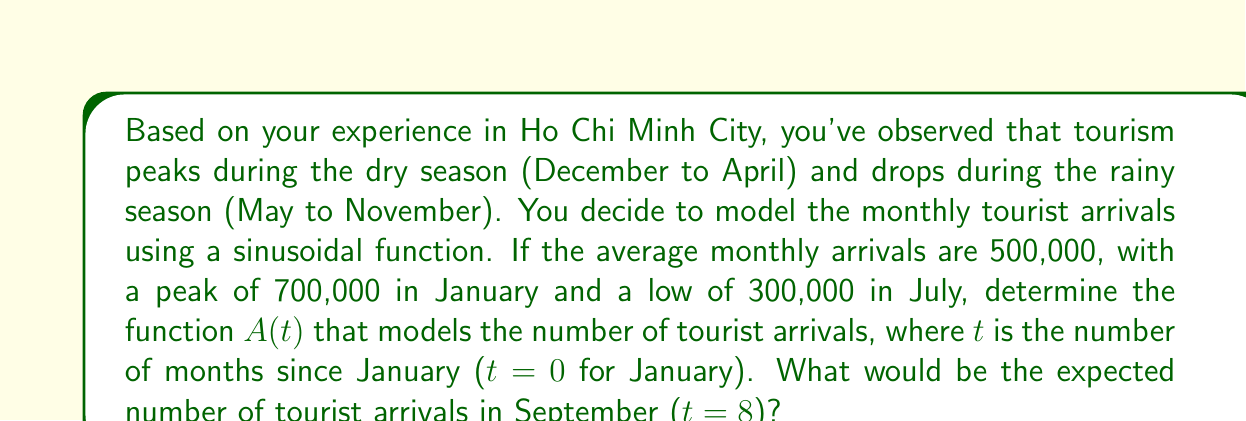Provide a solution to this math problem. To model the tourist arrivals, we'll use a sinusoidal function of the form:

$$A(t) = a \sin(bt + c) + d$$

Where:
$a$ is the amplitude
$b$ is the angular frequency
$c$ is the phase shift
$d$ is the vertical shift

Step 1: Determine the vertical shift (d)
The average of the maximum and minimum values:
$$d = \frac{700,000 + 300,000}{2} = 500,000$$

Step 2: Calculate the amplitude (a)
Half the difference between the maximum and minimum values:
$$a = \frac{700,000 - 300,000}{2} = 200,000$$

Step 3: Determine the period
The period is 12 months (one year). We know that $b = \frac{2\pi}{period}$, so:
$$b = \frac{2\pi}{12} = \frac{\pi}{6}$$

Step 4: Determine the phase shift (c)
Since the function peaks at t = 0 (January), there is no phase shift, so c = 0.

Step 5: Write the complete function
$$A(t) = 200,000 \sin(\frac{\pi}{6}t) + 500,000$$

Step 6: Calculate the expected arrivals for September (t = 8)
$$A(8) = 200,000 \sin(\frac{\pi}{6} \cdot 8) + 500,000$$
$$A(8) = 200,000 \sin(\frac{4\pi}{3}) + 500,000$$
$$A(8) = 200,000 \cdot (-\frac{\sqrt{3}}{2}) + 500,000$$
$$A(8) = -173,205 + 500,000 = 326,795$$

Therefore, the expected number of tourist arrivals in September is approximately 326,795.
Answer: 326,795 tourists 